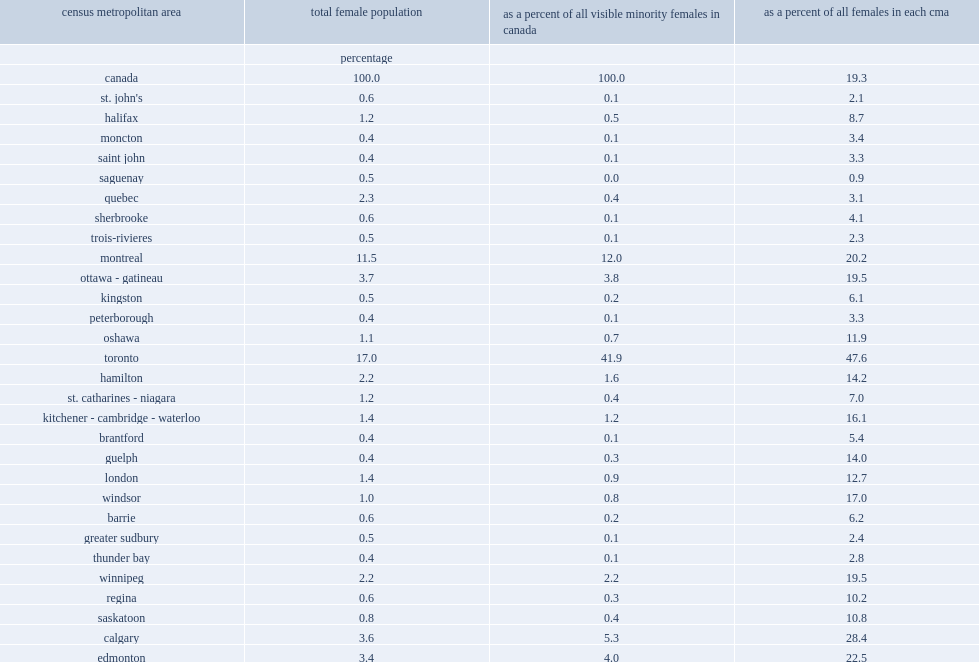What was the percentage of visible minority females lived in the cma of toronto? 41.9. What was the percentage of the total female population lived in the cma of toronto? 17.0. What was the percentage of the female visible minority population in the cma of vancouver? 16.7. What was the percentage of the female population in the cma of vancouver? 7.0. What was the share of the total female visible minority population in the cma of calgary? 5.3. What was the share of the total female population in the cma of calgary? 3.6. What was the share of visible minority women and girls living in the cma of montreal? 12.0. What was the share of the total female population lived in the cma of montreal? 11.5. 